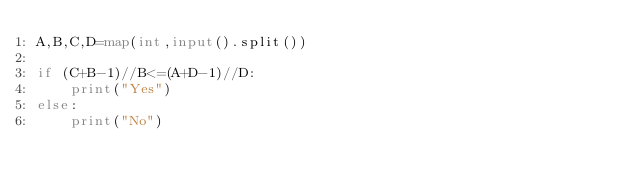<code> <loc_0><loc_0><loc_500><loc_500><_Python_>A,B,C,D=map(int,input().split())

if (C+B-1)//B<=(A+D-1)//D:
    print("Yes")
else:
    print("No")</code> 